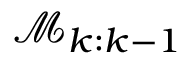Convert formula to latex. <formula><loc_0><loc_0><loc_500><loc_500>\mathcal { M } _ { k \colon k - 1 }</formula> 